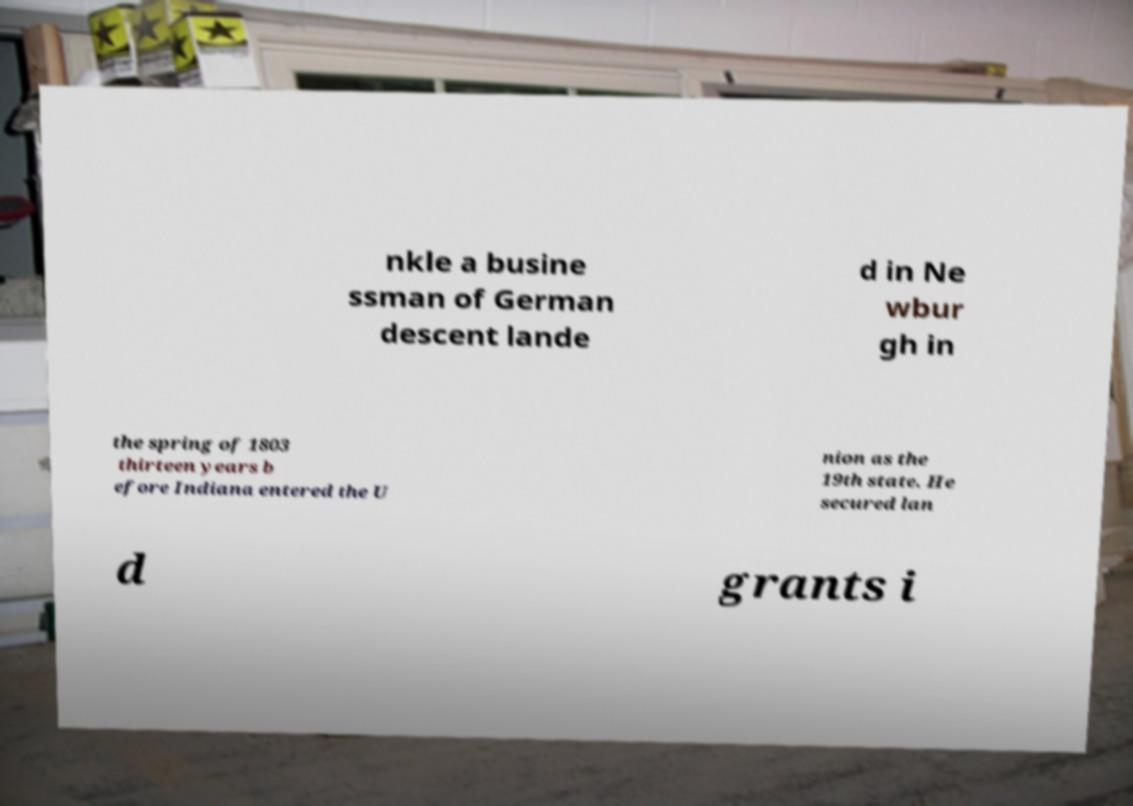Can you accurately transcribe the text from the provided image for me? nkle a busine ssman of German descent lande d in Ne wbur gh in the spring of 1803 thirteen years b efore Indiana entered the U nion as the 19th state. He secured lan d grants i 